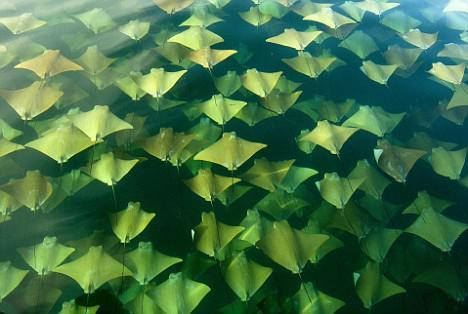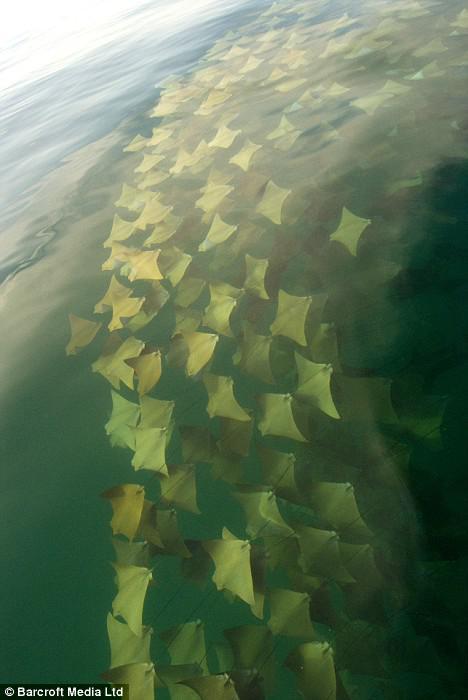The first image is the image on the left, the second image is the image on the right. For the images shown, is this caption "There is at least one human in the ocean in the left image." true? Answer yes or no. No. The first image is the image on the left, the second image is the image on the right. For the images displayed, is the sentence "Each image contains people in a body of water with rays in it." factually correct? Answer yes or no. No. 